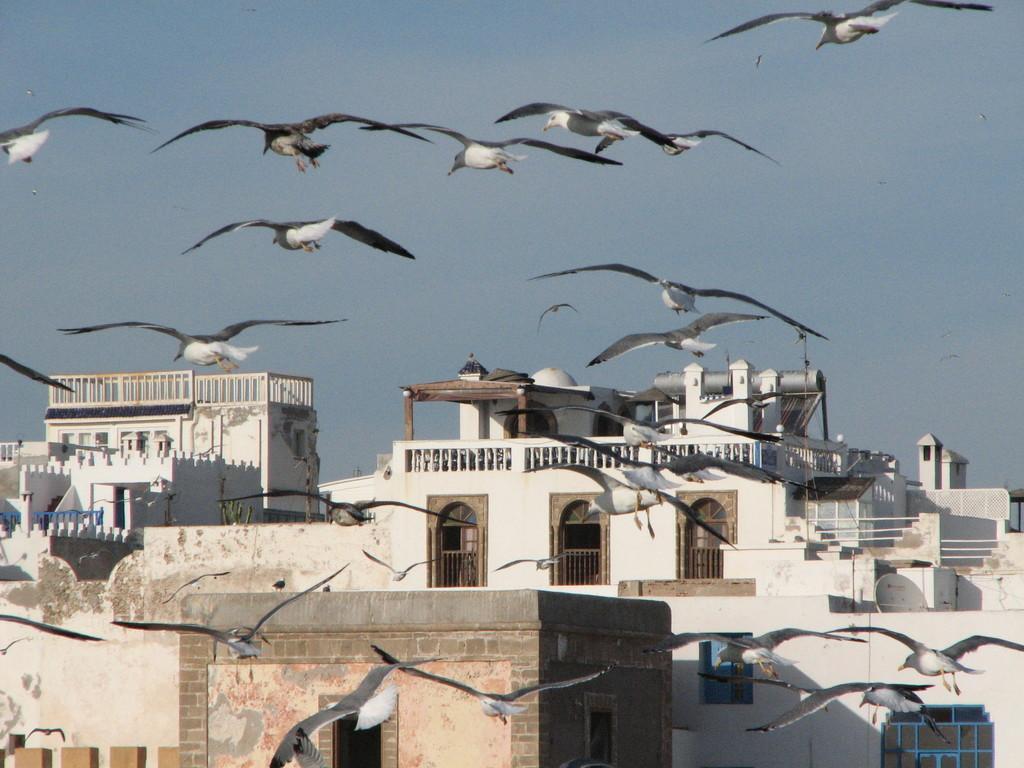In one or two sentences, can you explain what this image depicts? In this image there are some buildings at bottom of this image. There are some doors as we can see in middle of this image. There are some birds are at top of this image and bottom of this image ,and there is a sky in the background. 